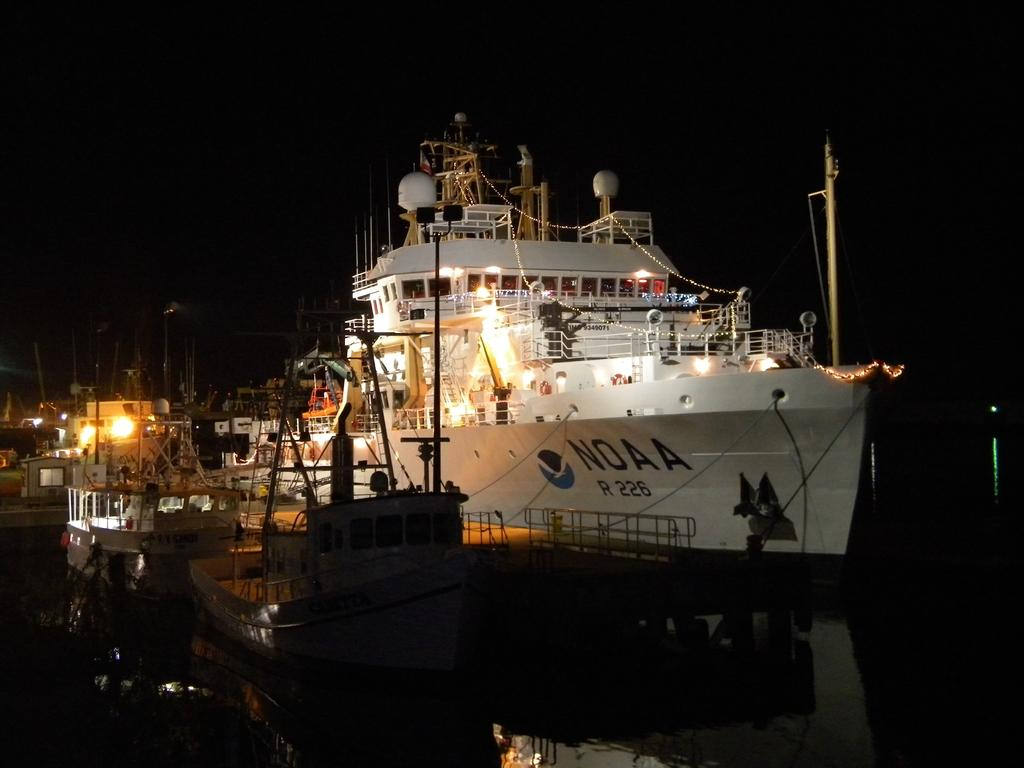What is present in the water in the image? There are fleets of boats in the water. What time of day is depicted in the image? The image is taken during night. Can you describe the location of the image based on the visible elements? The image may have been taken near a lake, as there are boats in the water. What can be seen in the sky in the image? The sky is visible in the image. What type of thread is being used to create the voice in the image? There is no thread or voice present in the image; it features fleets of boats in the water during nighttime. 